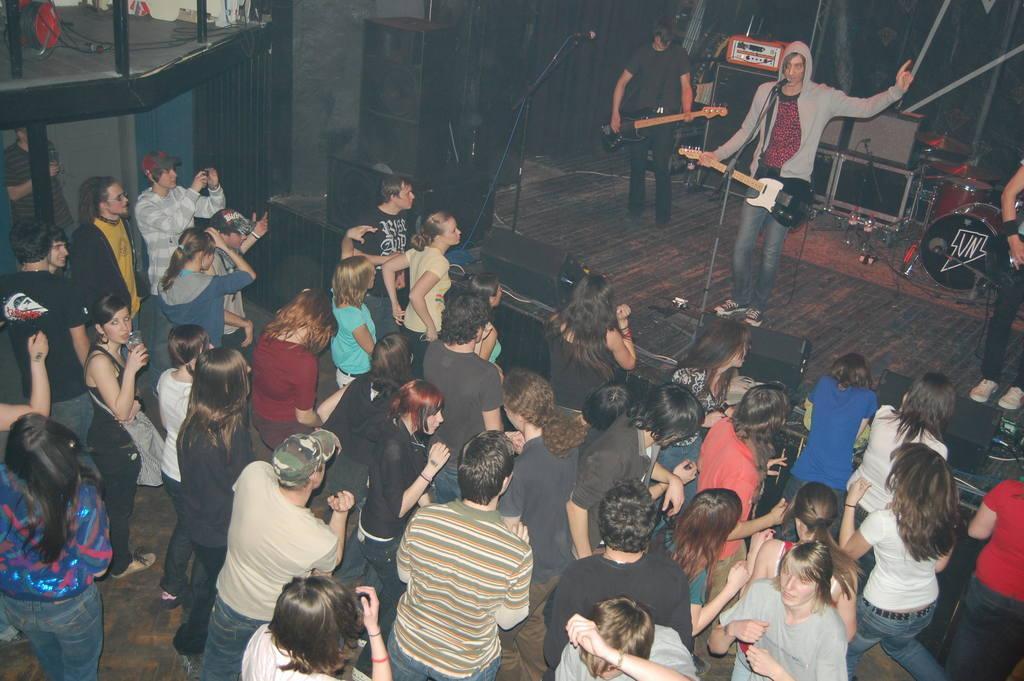Could you give a brief overview of what you see in this image? In the image there are many people standing. In front of them there is a stage with speakers, mics with stands and there are few people standing and playing musical instruments. Behind them there are few musical instruments. In the top left corner of the image there are rods. 